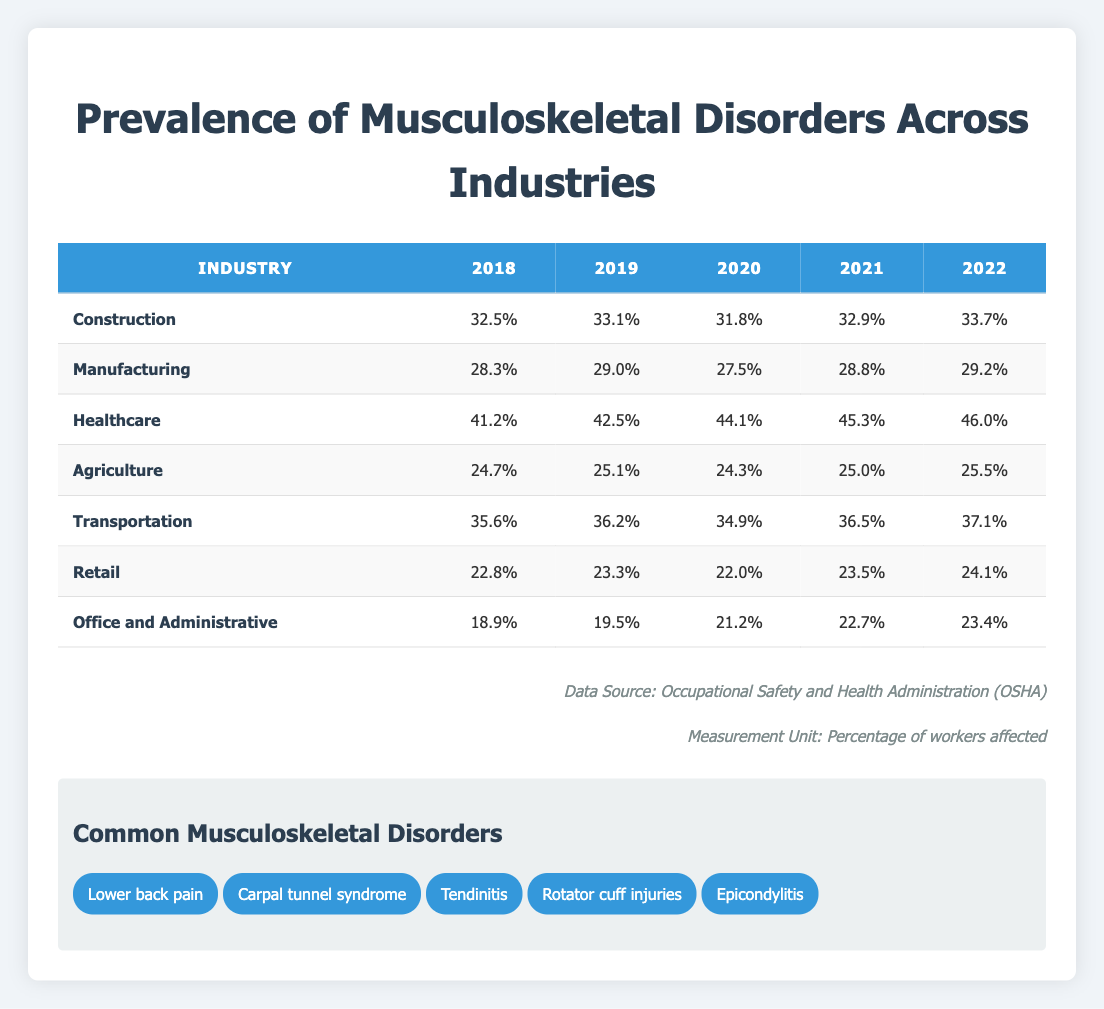What was the prevalence of musculoskeletal disorders in the Healthcare industry in 2020? The table indicates that in the year 2020, the prevalence of musculoskeletal disorders in the Healthcare industry was directly listed as 44.1%.
Answer: 44.1% Which industry had the highest prevalence of musculoskeletal disorders in 2022? From the table, the Healthcare industry had the highest prevalence of 46.0% in 2022 when compared to other industries, which had lower percentages.
Answer: Healthcare What is the average prevalence of musculoskeletal disorders in the Office and Administrative industry for the years 2018 to 2022? To find the average, we will sum the prevalence values from 2018 (18.9), 2019 (19.5), 2020 (21.2), 2021 (22.7), and 2022 (23.4), yielding a total of 105.7. We then divide by 5 to calculate the average: 105.7 / 5 = 21.14%.
Answer: 21.14% Is the prevalence of musculoskeletal disorders in the Agriculture industry greater than 25% in 2022? In the year 2022, the table indicates that the prevalence in Agriculture is 25.5%. Since 25.5% is greater than 25%, the answer is yes.
Answer: Yes What trend can we observe in the prevalence of musculoskeletal disorders for the Construction industry over the five years? The data shows an increase in prevalence for the Construction industry: 32.5% in 2018, up to 33.7% in 2022. This indicates a rising trend over the five-year period.
Answer: Increasing Which industry had the lowest prevalence in 2019? Referring to the table, the Retail industry had the lowest prevalence of musculoskeletal disorders in 2019 at 23.3%, which is lower than all the other industries listed.
Answer: Retail What is the difference in prevalence between the highest and lowest values for the Transportation industry from 2018 to 2022? The highest prevalence for Transportation was in 2022 at 37.1%, and the lowest was in 2018 at 35.6%. The difference is calculated as 37.1 - 35.6 = 1.5%.
Answer: 1.5% How many industries had a prevalence rate of 30% or higher in the year 2021? In 2021, the industries with 30% or higher prevalence are Construction (32.9%), Healthcare (45.3%), and Transportation (36.5%). This gives a total of 3 industries meeting this criterion.
Answer: 3 